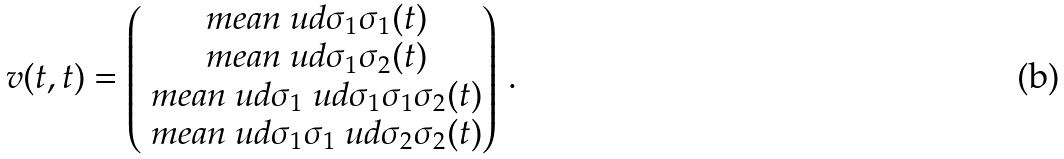Convert formula to latex. <formula><loc_0><loc_0><loc_500><loc_500>v ( t , t ) = \begin{pmatrix} \ m e a n { \ u d { \sigma _ { 1 } } \sigma _ { 1 } } ( t ) \\ \ m e a n { \ u d { \sigma _ { 1 } } \sigma _ { 2 } } ( t ) \\ \ m e a n { \ u d { \sigma _ { 1 } } \ u d { \sigma _ { 1 } } \sigma _ { 1 } \sigma _ { 2 } } ( t ) \\ \ m e a n { \ u d { \sigma _ { 1 } } \sigma _ { 1 } \ u d { \sigma _ { 2 } } \sigma _ { 2 } } ( t ) \end{pmatrix} \, .</formula> 